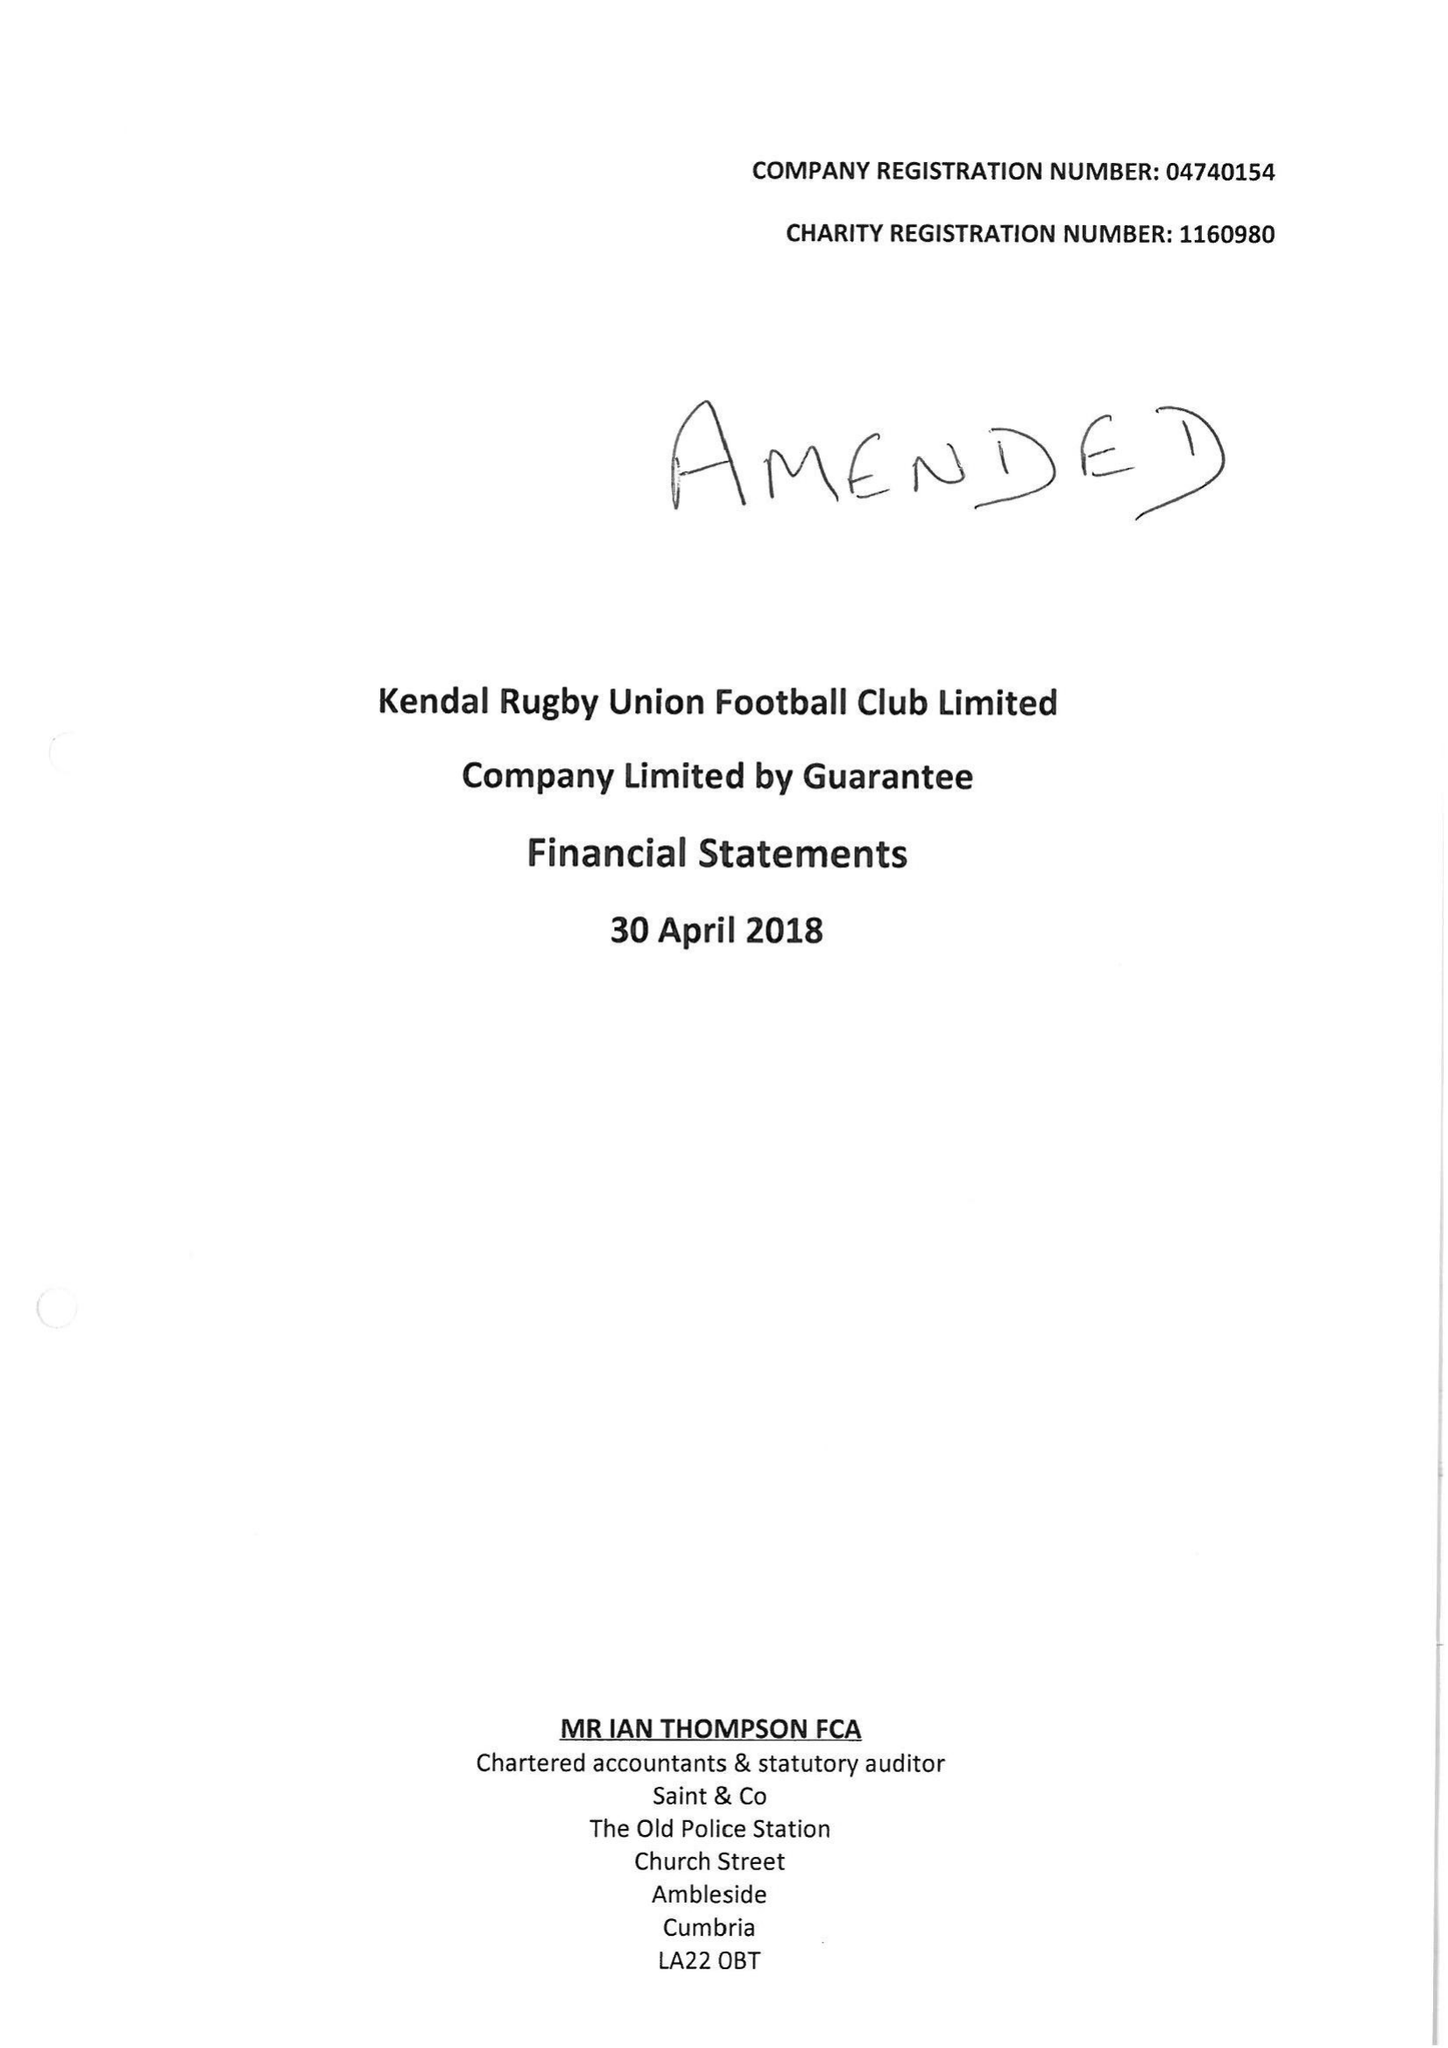What is the value for the address__street_line?
Answer the question using a single word or phrase. SHAP ROAD 